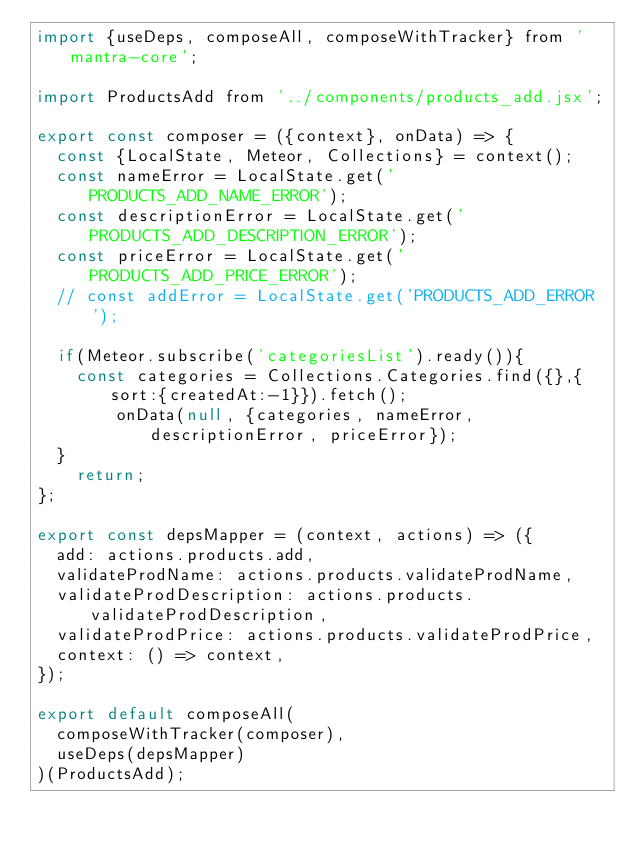Convert code to text. <code><loc_0><loc_0><loc_500><loc_500><_JavaScript_>import {useDeps, composeAll, composeWithTracker} from 'mantra-core';

import ProductsAdd from '../components/products_add.jsx';

export const composer = ({context}, onData) => {
  const {LocalState, Meteor, Collections} = context();
  const nameError = LocalState.get('PRODUCTS_ADD_NAME_ERROR');
  const descriptionError = LocalState.get('PRODUCTS_ADD_DESCRIPTION_ERROR');
  const priceError = LocalState.get('PRODUCTS_ADD_PRICE_ERROR');
  // const addError = LocalState.get('PRODUCTS_ADD_ERROR');

  if(Meteor.subscribe('categoriesList').ready()){
    const categories = Collections.Categories.find({},{sort:{createdAt:-1}}).fetch();
        onData(null, {categories, nameError, descriptionError, priceError});
  }
    return;
};

export const depsMapper = (context, actions) => ({
  add: actions.products.add,
  validateProdName: actions.products.validateProdName,
  validateProdDescription: actions.products.validateProdDescription,
  validateProdPrice: actions.products.validateProdPrice,
  context: () => context,
});

export default composeAll(
  composeWithTracker(composer),
  useDeps(depsMapper)
)(ProductsAdd);
</code> 